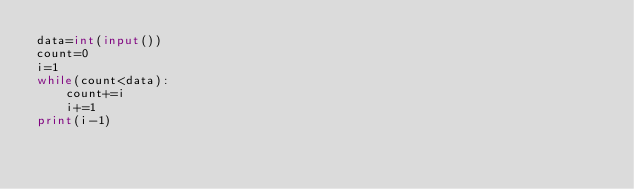<code> <loc_0><loc_0><loc_500><loc_500><_Python_>data=int(input())
count=0
i=1
while(count<data):
    count+=i
    i+=1
print(i-1)</code> 